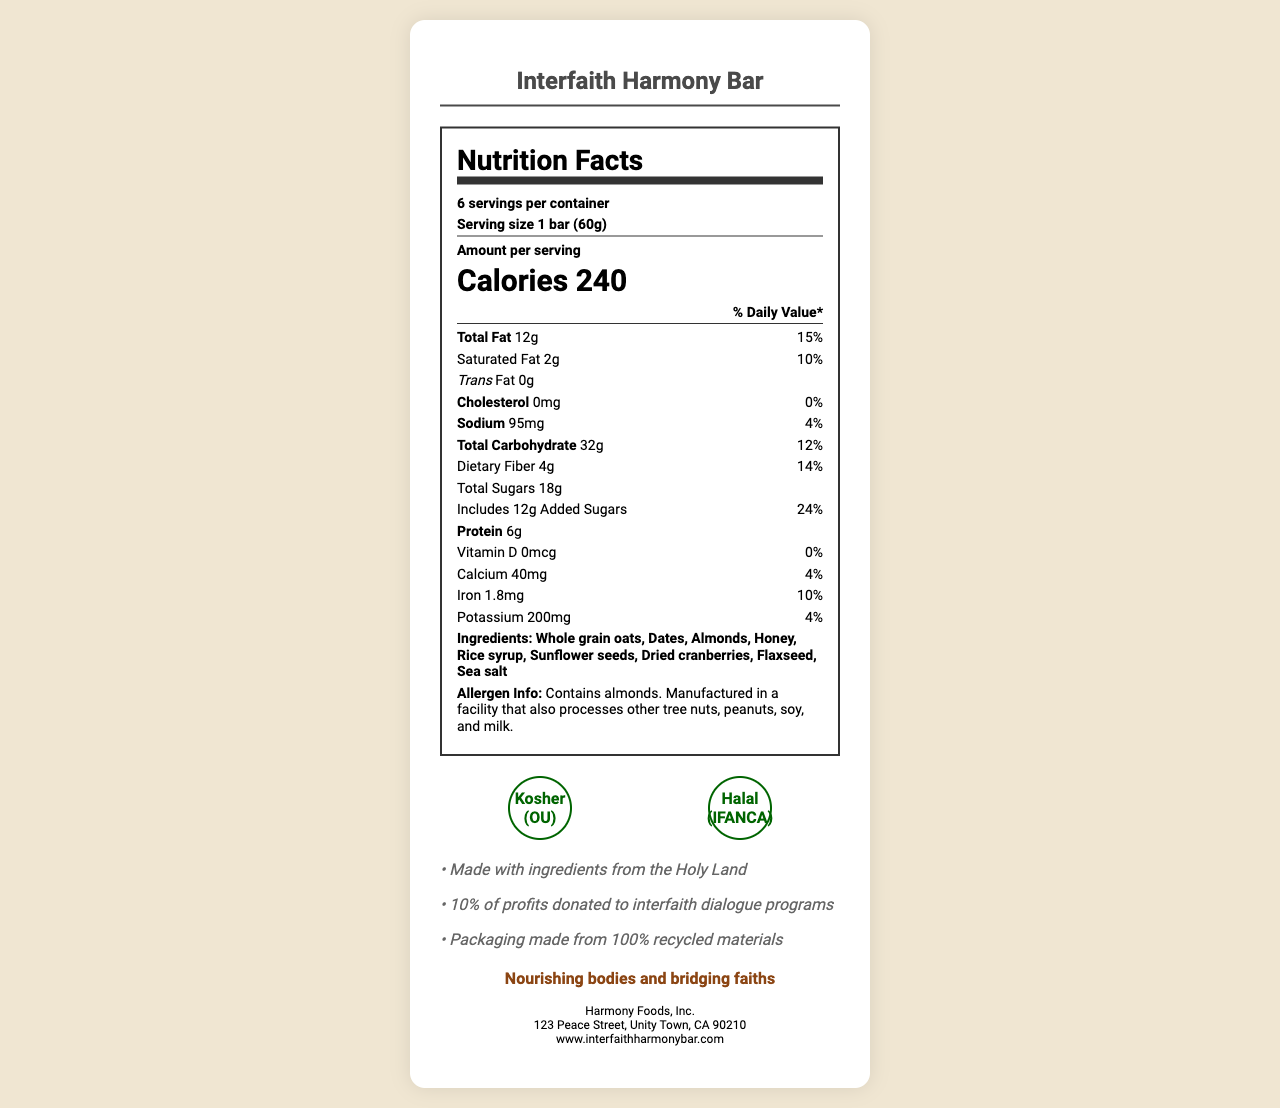what is the serving size? The serving size is clearly listed as "1 bar (60g)" in the document.
Answer: 1 bar (60g) how many servings are there per container? The document states that there are 6 servings per container.
Answer: 6 what are the total sugars in one serving? The document lists total sugars per serving as 18g.
Answer: 18g how much dietary fiber is in one serving? The dietary fiber amount per serving is specified as 4g.
Answer: 4g what percentage of the daily value of added sugars does one serving contain? The document indicates that one serving includes 12g of added sugars, which is 24% of the daily value.
Answer: 24% which of the following vitamins or minerals is not present in the Interfaith Harmony Bar? A. Vitamin D B. Calcium C. Iron D. Potassium The document shows that Vitamin D amount is 0mcg, which is 0% of the daily value.
Answer: A which ingredient is not listed in the Interfaith Harmony Bar? A. Almonds B. Flaxseed C. Peanuts D. Dates The ingredient list includes Almonds, Flaxseed, and Dates but not Peanuts.
Answer: C which certification does the Interfaith Harmony Bar have? A. Kosher (OU) B. Halal (IFANCA) C. Both A and B D. Neither The certifications mentioned are Kosher (OU) and Halal (IFANCA), so the correct answer is both A and B.
Answer: C are saturated fats present in the Interfaith Harmony Bar? The document lists 2g of saturated fat per serving, which is 10% of the daily value.
Answer: Yes please summarize the main information provided on the document. The explanation includes the main parts of the document, citing key points such as nutritional contents, ingredients, certifications, and the mission of promoting interfaith dialogue.
Answer: The document provides a detailed nutrition facts label for the Interfaith Harmony Bar, a kosher and halal-certified snack. It includes information on serving size, calories, fats, cholesterol, sodium, carbohydrates, sugars, fiber, protein, vitamins, minerals, ingredients, allergen information, and certifications. The snack promotes interfaith dialogue by donating 10% of its profits and uses ingredients from the Holy Land. The packaging is environmentally friendly. The manufacturer is Harmony Foods, Inc., located in Unity Town, CA. how many calories are there per serving? The document specifies that each serving contains 240 calories.
Answer: 240 what is the total fat content per serving? The document lists the total fat content as 12g per serving, which is 15% of the daily value.
Answer: 12g which ingredients might present an allergen risk? The allergen information states the product contains almonds and is manufactured in a facility that also processes other tree nuts, peanuts, soy, and milk.
Answer: Almonds, other tree nuts, peanuts, soy, and milk what is the manufacturer's address? The manufacturer's address is listed as 123 Peace Street, Unity Town, CA 90210.
Answer: 123 Peace Street, Unity Town, CA 90210 how does the company contribute to promoting interfaith dialogue? The document mentions that 10% of the profits from the bar are donated to support interfaith dialogue programs.
Answer: 10% of profits donated to interfaith dialogue programs what is the total carbohydrate content per serving? The total carbohydrate content per serving is given as 32g in the document.
Answer: 32g where are the ingredients of the Interfaith Harmony Bar sourced from? The document states the bar is made with ingredients from the Holy Land.
Answer: Made with ingredients from the Holy Land does the Interfaith Harmony Bar contain any trans fat? According to the document, the bar contains 0g of trans fat.
Answer: No what does the slogan of the Interfaith Harmony Bar say? The slogan mentioned in the document is "Nourishing bodies and bridging faiths."
Answer: Nourishing bodies and bridging faiths how much vitamin D is in one serving of the Interfaith Harmony Bar? The document indicates that there is no vitamin D (0mcg) in one serving.
Answer: 0mcg are there any certifications related to the environmental aspects of the Interfaith Harmony Bar? The document does not provide any certificates related to environmental aspects, only stating the packaging is made from 100% recycled materials. Thus, it cannot be determined if there are any official environmental certifications.
Answer: Not mentioned 